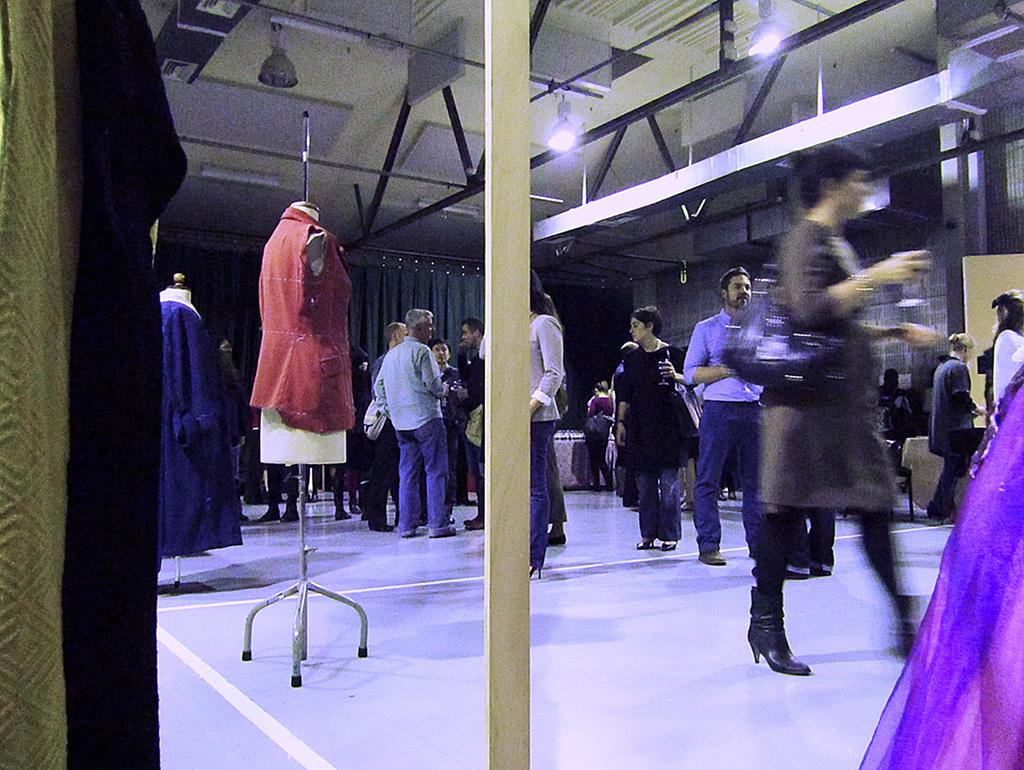What is the main subject in the middle of the image? There is a group of persons in the middle of the image. What can be seen at the top of the image? There is a roof visible at the top of the image. What is located on the left side of the image? There are mannequins on the left side of the image. How many cakes are being served to the visitors in the image? There is no mention of cakes or visitors in the image; it features a group of persons, a roof, and mannequins. What type of swimwear are the persons wearing in the image? There is no indication of swimwear or swimming activities in the image. 